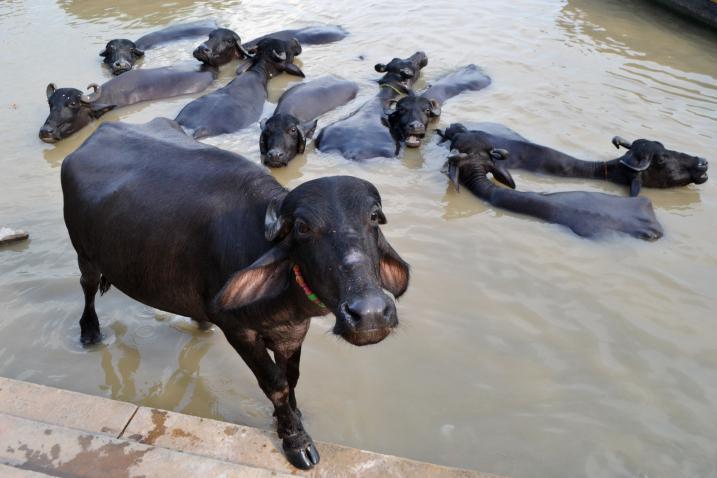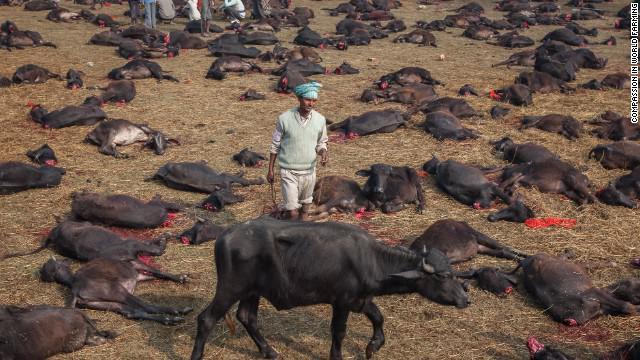The first image is the image on the left, the second image is the image on the right. Examine the images to the left and right. Is the description "there are some oxen in water." accurate? Answer yes or no. Yes. The first image is the image on the left, the second image is the image on the right. Assess this claim about the two images: "There is at least one human visible.". Correct or not? Answer yes or no. Yes. 